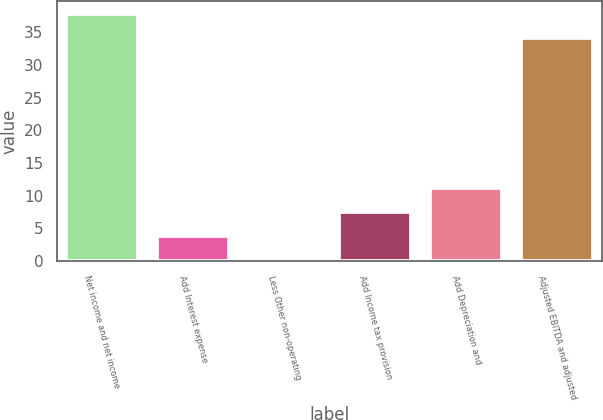Convert chart. <chart><loc_0><loc_0><loc_500><loc_500><bar_chart><fcel>Net income and net income<fcel>Add Interest expense<fcel>Less Other non-operating<fcel>Add Income tax provision<fcel>Add Depreciation and<fcel>Adjusted EBITDA and adjusted<nl><fcel>37.87<fcel>3.87<fcel>0.2<fcel>7.54<fcel>11.21<fcel>34.2<nl></chart> 